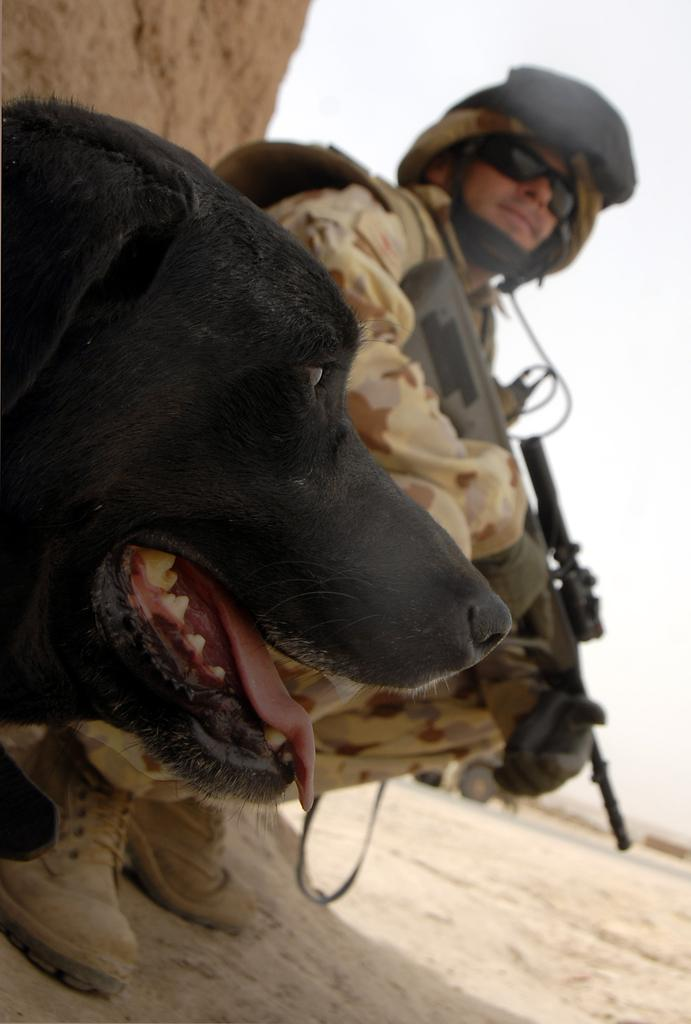What type of animal is in the image? There is a dog in the image. Who else is present in the image? There is a soldier in the image. What is the ground made of in the image? There is sand at the bottom of the image. What can be seen in the background of the image? There is a vehicle visible in the background of the image. What is the vehicle's location in relation to the road? The vehicle is on a road. How many glasses are on the table in the image? There is no table or glass present in the image. What type of cent is visible in the image? There is no cent present in the image. 